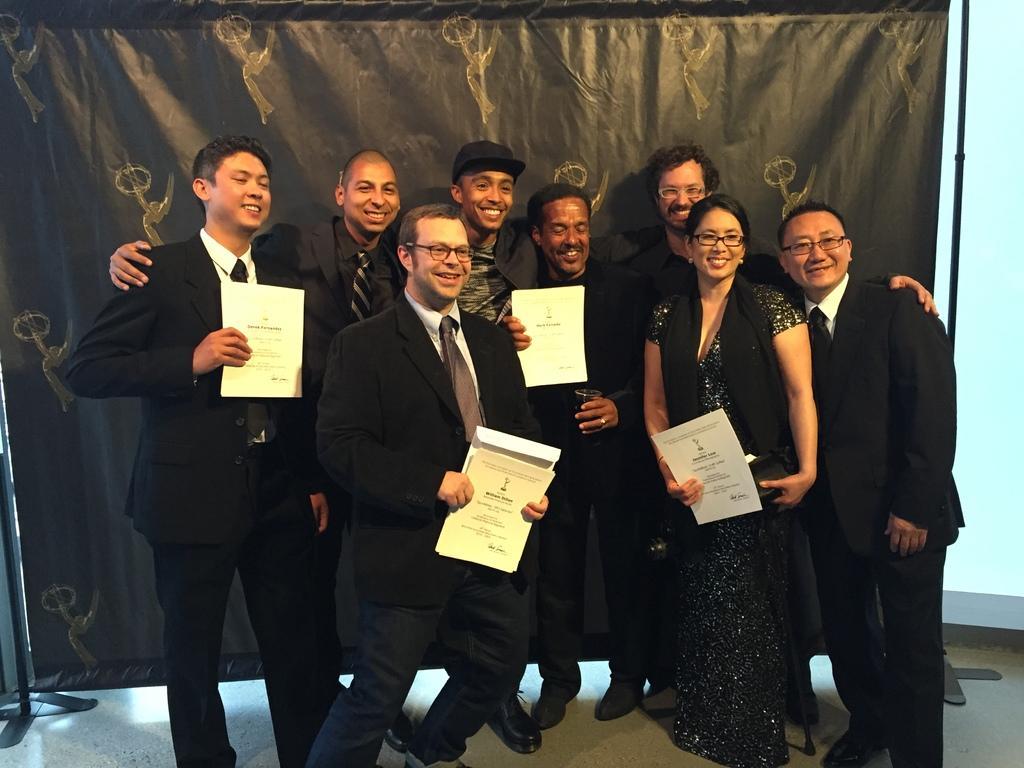Could you give a brief overview of what you see in this image? In the image there are few men and a woman in black dress holding papers and standing in the front of a black curtain and behind it there is wall. 